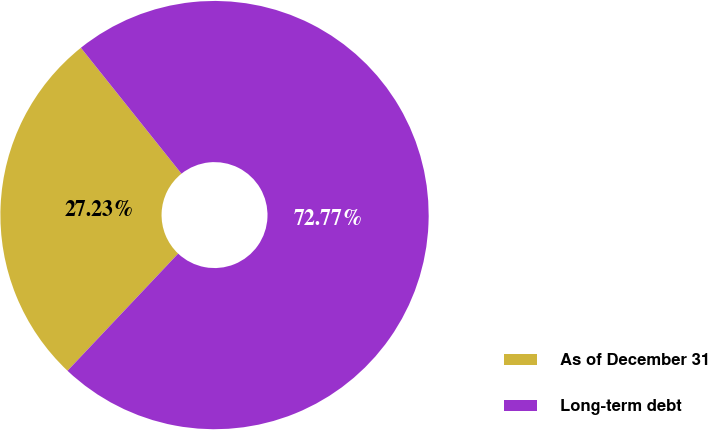Convert chart. <chart><loc_0><loc_0><loc_500><loc_500><pie_chart><fcel>As of December 31<fcel>Long-term debt<nl><fcel>27.23%<fcel>72.77%<nl></chart> 